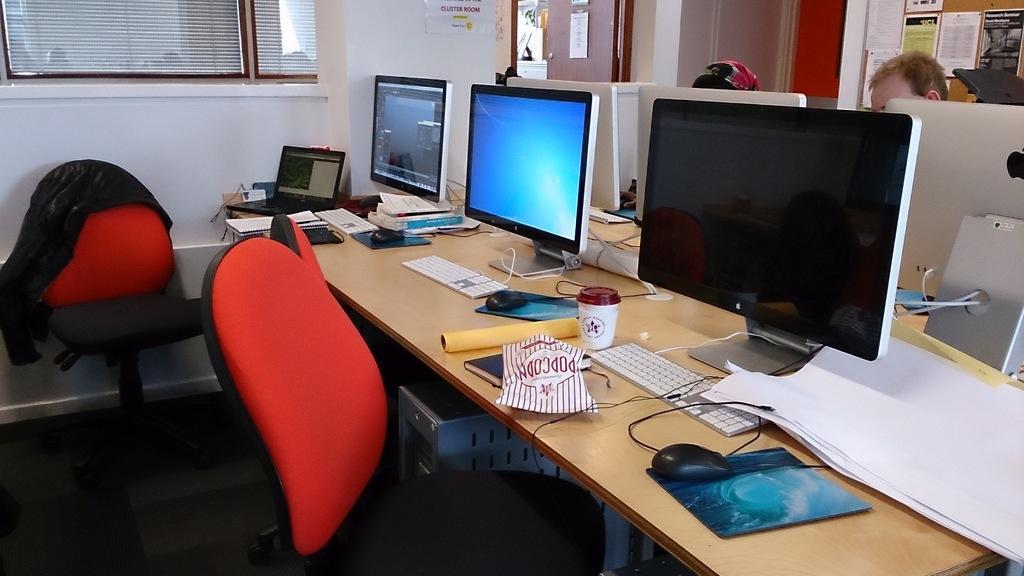In one or two sentences, can you explain what this image depicts? On the right side of the image we can see persons and table. On the table we can see monitors, keyboards, mouse, mouse pads, papers, cup and laptop. On the left side of the image we can see chairs. In the background we can see wall, window and door. 